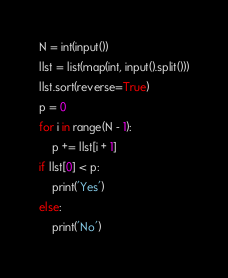<code> <loc_0><loc_0><loc_500><loc_500><_Python_>N = int(input())
llst = list(map(int, input().split()))
llst.sort(reverse=True)
p = 0
for i in range(N - 1):
    p += llst[i + 1]
if llst[0] < p:
    print('Yes')
else:
    print('No')</code> 